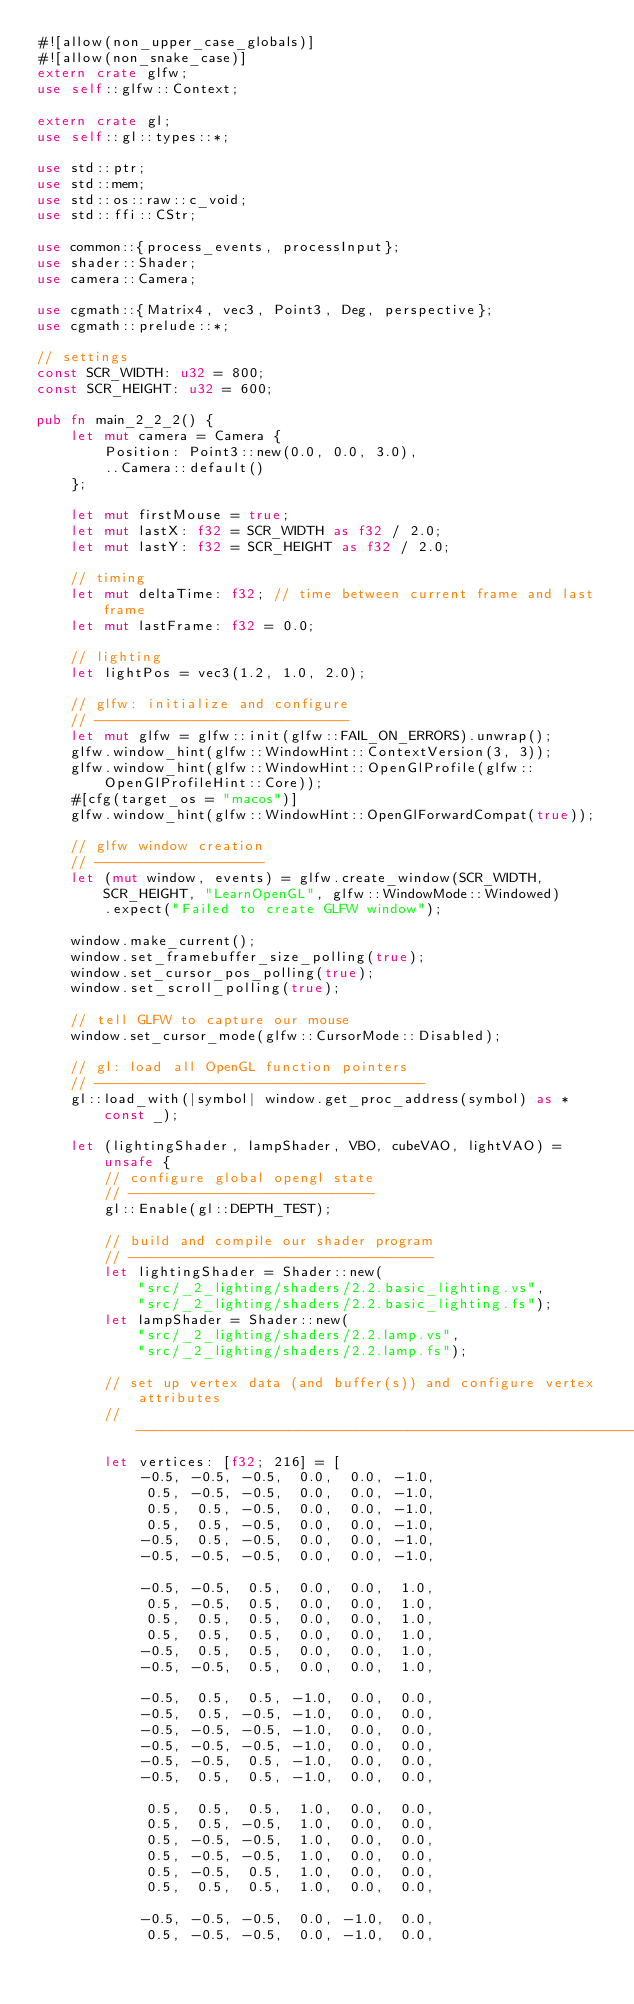Convert code to text. <code><loc_0><loc_0><loc_500><loc_500><_Rust_>#![allow(non_upper_case_globals)]
#![allow(non_snake_case)]
extern crate glfw;
use self::glfw::Context;

extern crate gl;
use self::gl::types::*;

use std::ptr;
use std::mem;
use std::os::raw::c_void;
use std::ffi::CStr;

use common::{process_events, processInput};
use shader::Shader;
use camera::Camera;

use cgmath::{Matrix4, vec3, Point3, Deg, perspective};
use cgmath::prelude::*;

// settings
const SCR_WIDTH: u32 = 800;
const SCR_HEIGHT: u32 = 600;

pub fn main_2_2_2() {
    let mut camera = Camera {
        Position: Point3::new(0.0, 0.0, 3.0),
        ..Camera::default()
    };

    let mut firstMouse = true;
    let mut lastX: f32 = SCR_WIDTH as f32 / 2.0;
    let mut lastY: f32 = SCR_HEIGHT as f32 / 2.0;

    // timing
    let mut deltaTime: f32; // time between current frame and last frame
    let mut lastFrame: f32 = 0.0;

    // lighting
    let lightPos = vec3(1.2, 1.0, 2.0);

    // glfw: initialize and configure
    // ------------------------------
    let mut glfw = glfw::init(glfw::FAIL_ON_ERRORS).unwrap();
    glfw.window_hint(glfw::WindowHint::ContextVersion(3, 3));
    glfw.window_hint(glfw::WindowHint::OpenGlProfile(glfw::OpenGlProfileHint::Core));
    #[cfg(target_os = "macos")]
    glfw.window_hint(glfw::WindowHint::OpenGlForwardCompat(true));

    // glfw window creation
    // --------------------
    let (mut window, events) = glfw.create_window(SCR_WIDTH, SCR_HEIGHT, "LearnOpenGL", glfw::WindowMode::Windowed)
        .expect("Failed to create GLFW window");

    window.make_current();
    window.set_framebuffer_size_polling(true);
    window.set_cursor_pos_polling(true);
    window.set_scroll_polling(true);

    // tell GLFW to capture our mouse
    window.set_cursor_mode(glfw::CursorMode::Disabled);

    // gl: load all OpenGL function pointers
    // ---------------------------------------
    gl::load_with(|symbol| window.get_proc_address(symbol) as *const _);

    let (lightingShader, lampShader, VBO, cubeVAO, lightVAO) = unsafe {
        // configure global opengl state
        // -----------------------------
        gl::Enable(gl::DEPTH_TEST);

        // build and compile our shader program
        // ------------------------------------
        let lightingShader = Shader::new(
            "src/_2_lighting/shaders/2.2.basic_lighting.vs",
            "src/_2_lighting/shaders/2.2.basic_lighting.fs");
        let lampShader = Shader::new(
            "src/_2_lighting/shaders/2.2.lamp.vs",
            "src/_2_lighting/shaders/2.2.lamp.fs");

        // set up vertex data (and buffer(s)) and configure vertex attributes
        // ------------------------------------------------------------------
        let vertices: [f32; 216] = [
            -0.5, -0.5, -0.5,  0.0,  0.0, -1.0,
             0.5, -0.5, -0.5,  0.0,  0.0, -1.0,
             0.5,  0.5, -0.5,  0.0,  0.0, -1.0,
             0.5,  0.5, -0.5,  0.0,  0.0, -1.0,
            -0.5,  0.5, -0.5,  0.0,  0.0, -1.0,
            -0.5, -0.5, -0.5,  0.0,  0.0, -1.0,

            -0.5, -0.5,  0.5,  0.0,  0.0,  1.0,
             0.5, -0.5,  0.5,  0.0,  0.0,  1.0,
             0.5,  0.5,  0.5,  0.0,  0.0,  1.0,
             0.5,  0.5,  0.5,  0.0,  0.0,  1.0,
            -0.5,  0.5,  0.5,  0.0,  0.0,  1.0,
            -0.5, -0.5,  0.5,  0.0,  0.0,  1.0,

            -0.5,  0.5,  0.5, -1.0,  0.0,  0.0,
            -0.5,  0.5, -0.5, -1.0,  0.0,  0.0,
            -0.5, -0.5, -0.5, -1.0,  0.0,  0.0,
            -0.5, -0.5, -0.5, -1.0,  0.0,  0.0,
            -0.5, -0.5,  0.5, -1.0,  0.0,  0.0,
            -0.5,  0.5,  0.5, -1.0,  0.0,  0.0,

             0.5,  0.5,  0.5,  1.0,  0.0,  0.0,
             0.5,  0.5, -0.5,  1.0,  0.0,  0.0,
             0.5, -0.5, -0.5,  1.0,  0.0,  0.0,
             0.5, -0.5, -0.5,  1.0,  0.0,  0.0,
             0.5, -0.5,  0.5,  1.0,  0.0,  0.0,
             0.5,  0.5,  0.5,  1.0,  0.0,  0.0,

            -0.5, -0.5, -0.5,  0.0, -1.0,  0.0,
             0.5, -0.5, -0.5,  0.0, -1.0,  0.0,</code> 